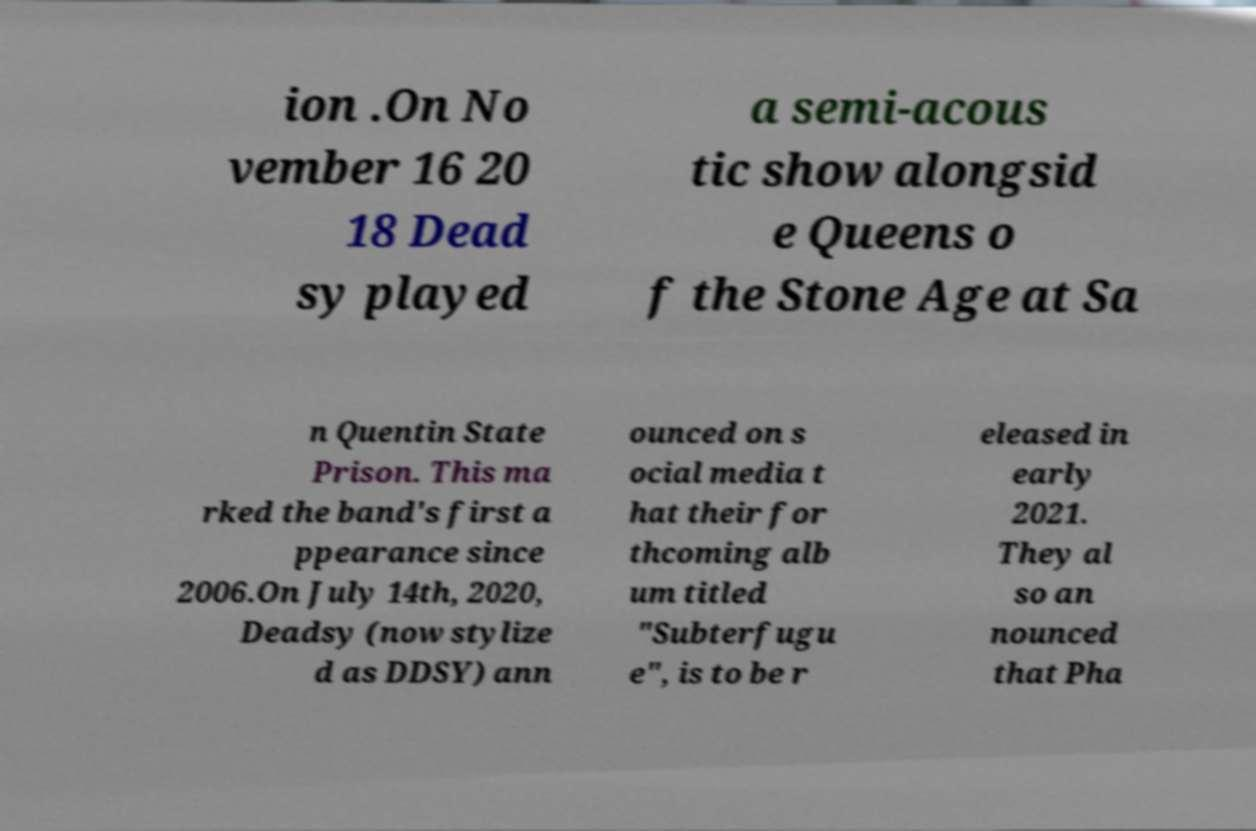Please read and relay the text visible in this image. What does it say? ion .On No vember 16 20 18 Dead sy played a semi-acous tic show alongsid e Queens o f the Stone Age at Sa n Quentin State Prison. This ma rked the band's first a ppearance since 2006.On July 14th, 2020, Deadsy (now stylize d as DDSY) ann ounced on s ocial media t hat their for thcoming alb um titled "Subterfugu e", is to be r eleased in early 2021. They al so an nounced that Pha 